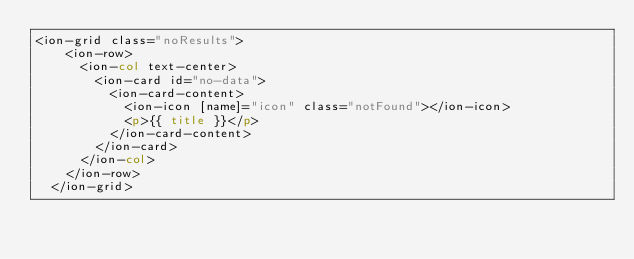<code> <loc_0><loc_0><loc_500><loc_500><_HTML_><ion-grid class="noResults">
    <ion-row>
      <ion-col text-center>
        <ion-card id="no-data">
          <ion-card-content>
            <ion-icon [name]="icon" class="notFound"></ion-icon>
            <p>{{ title }}</p>
          </ion-card-content>
        </ion-card>        
      </ion-col>
    </ion-row>
  </ion-grid></code> 